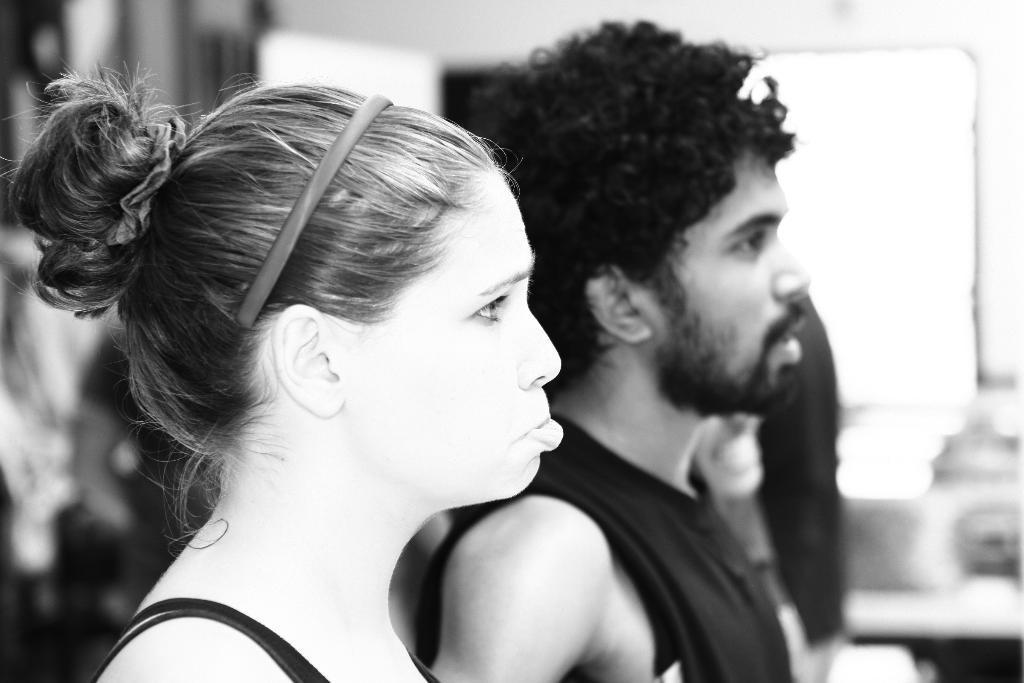In one or two sentences, can you explain what this image depicts? In this image I can see two people with the dresses. I can see one person with the hair band. And there is a blurred background. This a black and white image. 